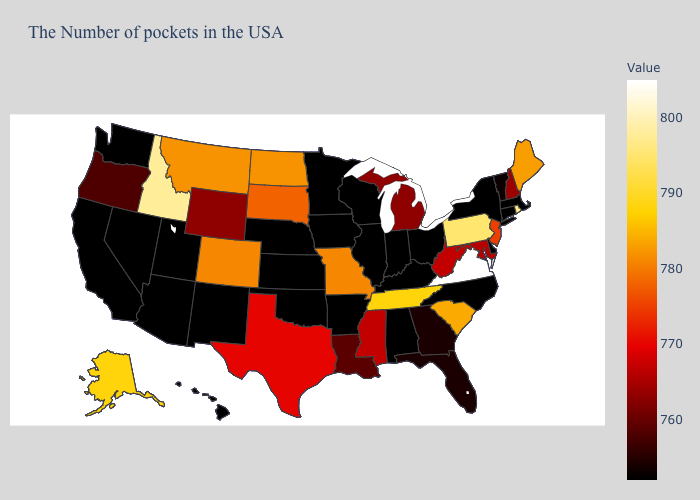Is the legend a continuous bar?
Short answer required. Yes. Which states have the highest value in the USA?
Be succinct. Virginia. 